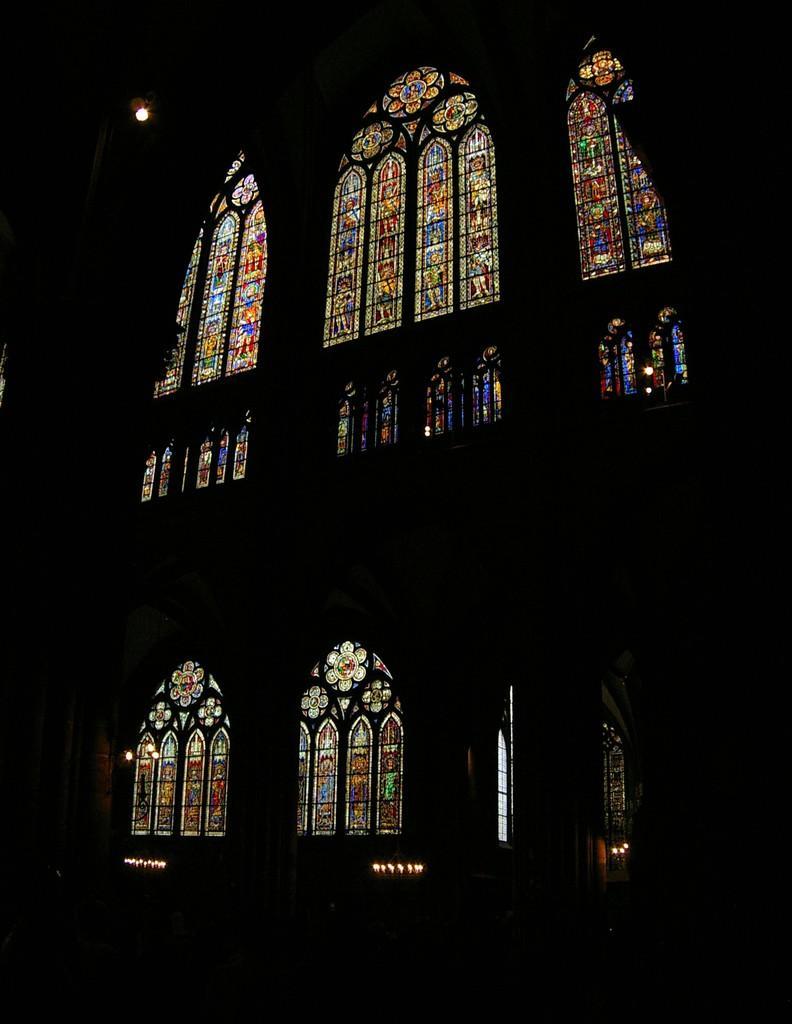Describe this image in one or two sentences. This picture is very dark and we can see painting on glass and we can see light. 